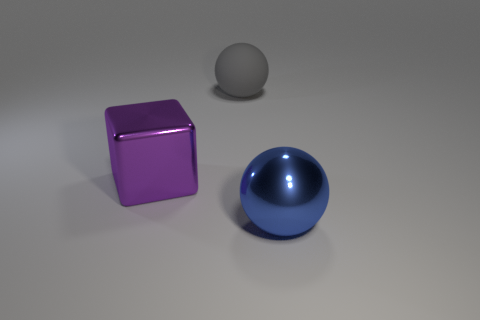What materials do the objects appear to be made of? The objects have different textures suggesting various materials. The purple cube seems metallic due to its shiny surface and sharp reflections, the sphere in the middle has a matte finish typical of a plastic or ceramic surface, and the blue sphere looks glossy, indicating a polished, potentially metallic or glass-like material. 